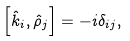Convert formula to latex. <formula><loc_0><loc_0><loc_500><loc_500>\left [ \hat { k } _ { i } , \hat { \rho } _ { j } \right ] = - i \delta _ { i j } ,</formula> 